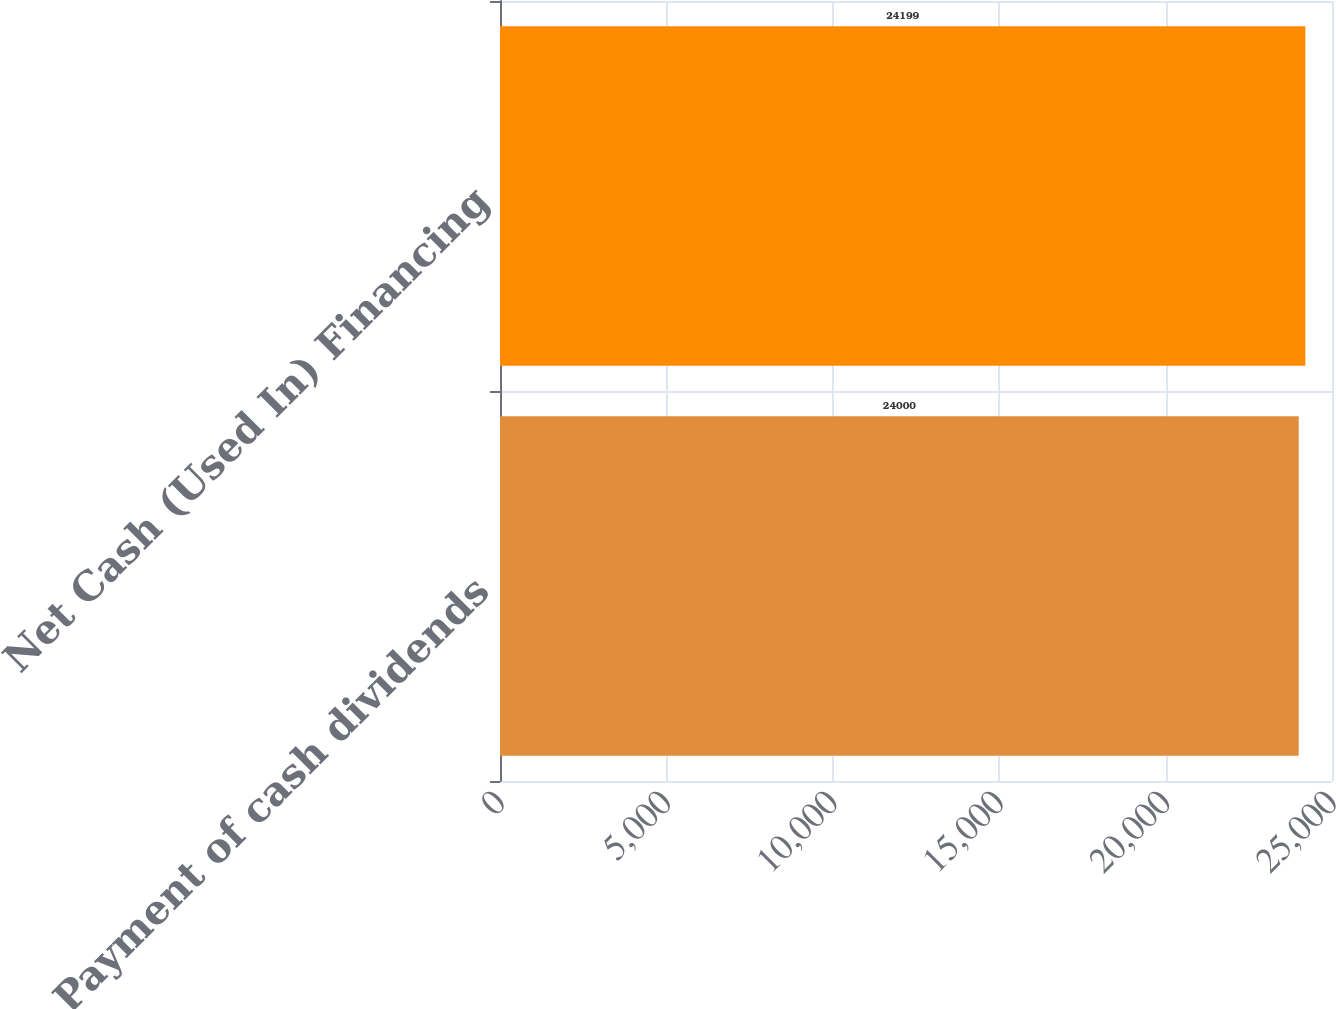Convert chart to OTSL. <chart><loc_0><loc_0><loc_500><loc_500><bar_chart><fcel>Payment of cash dividends<fcel>Net Cash (Used In) Financing<nl><fcel>24000<fcel>24199<nl></chart> 